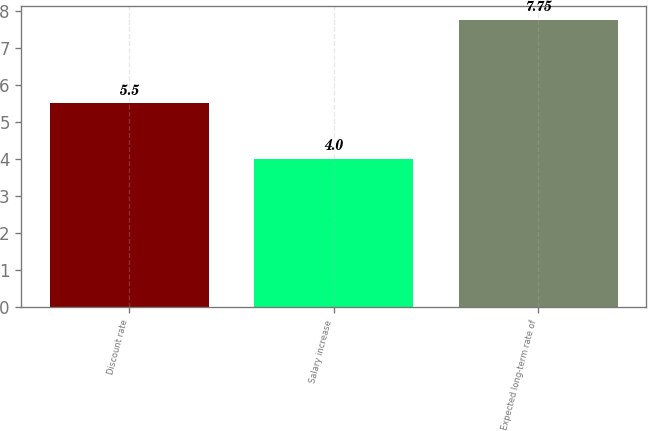<chart> <loc_0><loc_0><loc_500><loc_500><bar_chart><fcel>Discount rate<fcel>Salary increase<fcel>Expected long-term rate of<nl><fcel>5.5<fcel>4<fcel>7.75<nl></chart> 